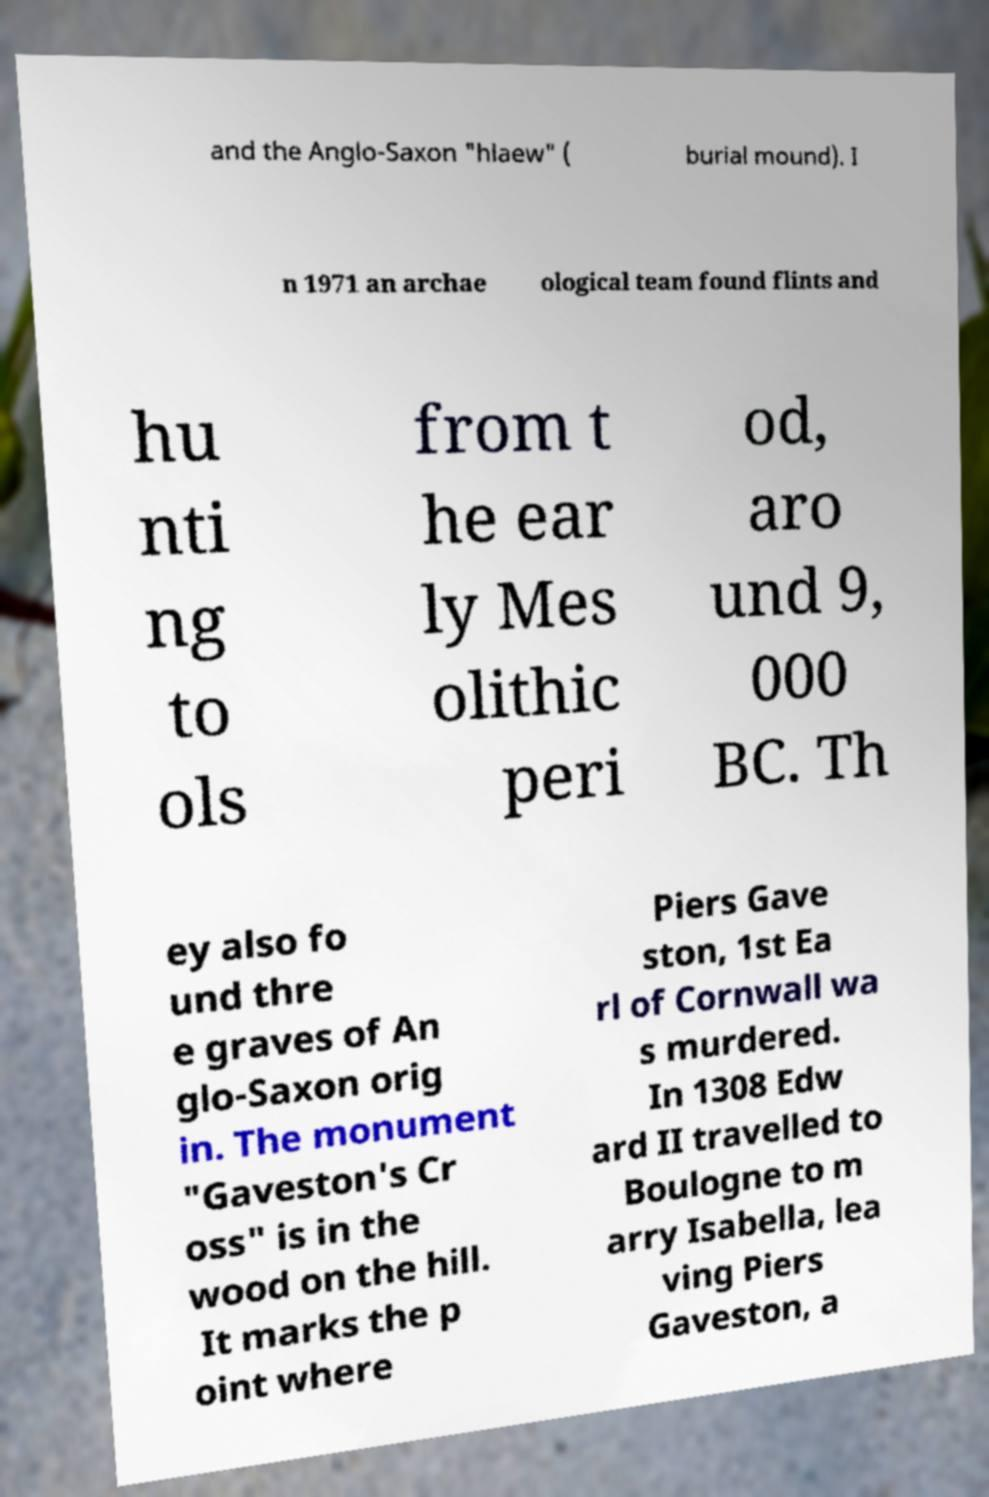Could you assist in decoding the text presented in this image and type it out clearly? and the Anglo-Saxon "hlaew" ( burial mound). I n 1971 an archae ological team found flints and hu nti ng to ols from t he ear ly Mes olithic peri od, aro und 9, 000 BC. Th ey also fo und thre e graves of An glo-Saxon orig in. The monument "Gaveston's Cr oss" is in the wood on the hill. It marks the p oint where Piers Gave ston, 1st Ea rl of Cornwall wa s murdered. In 1308 Edw ard II travelled to Boulogne to m arry Isabella, lea ving Piers Gaveston, a 